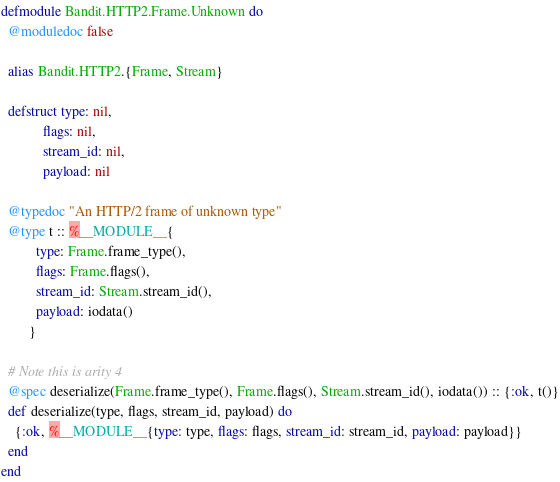<code> <loc_0><loc_0><loc_500><loc_500><_Elixir_>defmodule Bandit.HTTP2.Frame.Unknown do
  @moduledoc false

  alias Bandit.HTTP2.{Frame, Stream}

  defstruct type: nil,
            flags: nil,
            stream_id: nil,
            payload: nil

  @typedoc "An HTTP/2 frame of unknown type"
  @type t :: %__MODULE__{
          type: Frame.frame_type(),
          flags: Frame.flags(),
          stream_id: Stream.stream_id(),
          payload: iodata()
        }

  # Note this is arity 4
  @spec deserialize(Frame.frame_type(), Frame.flags(), Stream.stream_id(), iodata()) :: {:ok, t()}
  def deserialize(type, flags, stream_id, payload) do
    {:ok, %__MODULE__{type: type, flags: flags, stream_id: stream_id, payload: payload}}
  end
end
</code> 